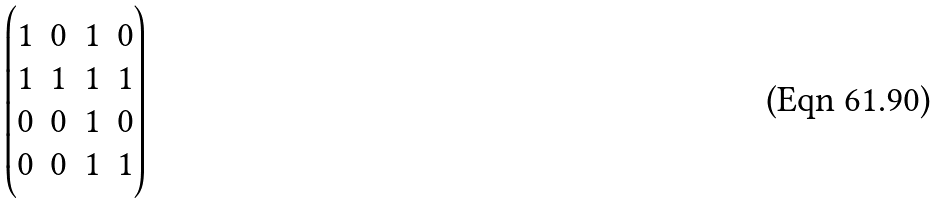Convert formula to latex. <formula><loc_0><loc_0><loc_500><loc_500>\begin{pmatrix} 1 & 0 & 1 & 0 \\ 1 & 1 & 1 & 1 \\ 0 & 0 & 1 & 0 \\ 0 & 0 & 1 & 1 \end{pmatrix}</formula> 